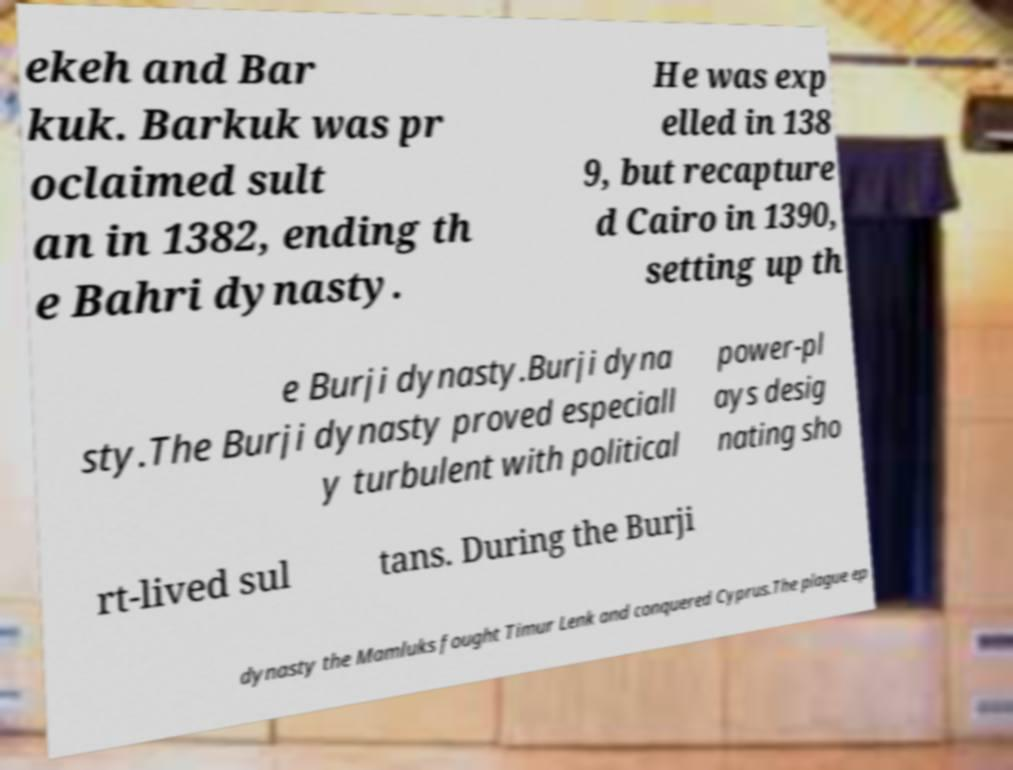Please identify and transcribe the text found in this image. ekeh and Bar kuk. Barkuk was pr oclaimed sult an in 1382, ending th e Bahri dynasty. He was exp elled in 138 9, but recapture d Cairo in 1390, setting up th e Burji dynasty.Burji dyna sty.The Burji dynasty proved especiall y turbulent with political power-pl ays desig nating sho rt-lived sul tans. During the Burji dynasty the Mamluks fought Timur Lenk and conquered Cyprus.The plague ep 